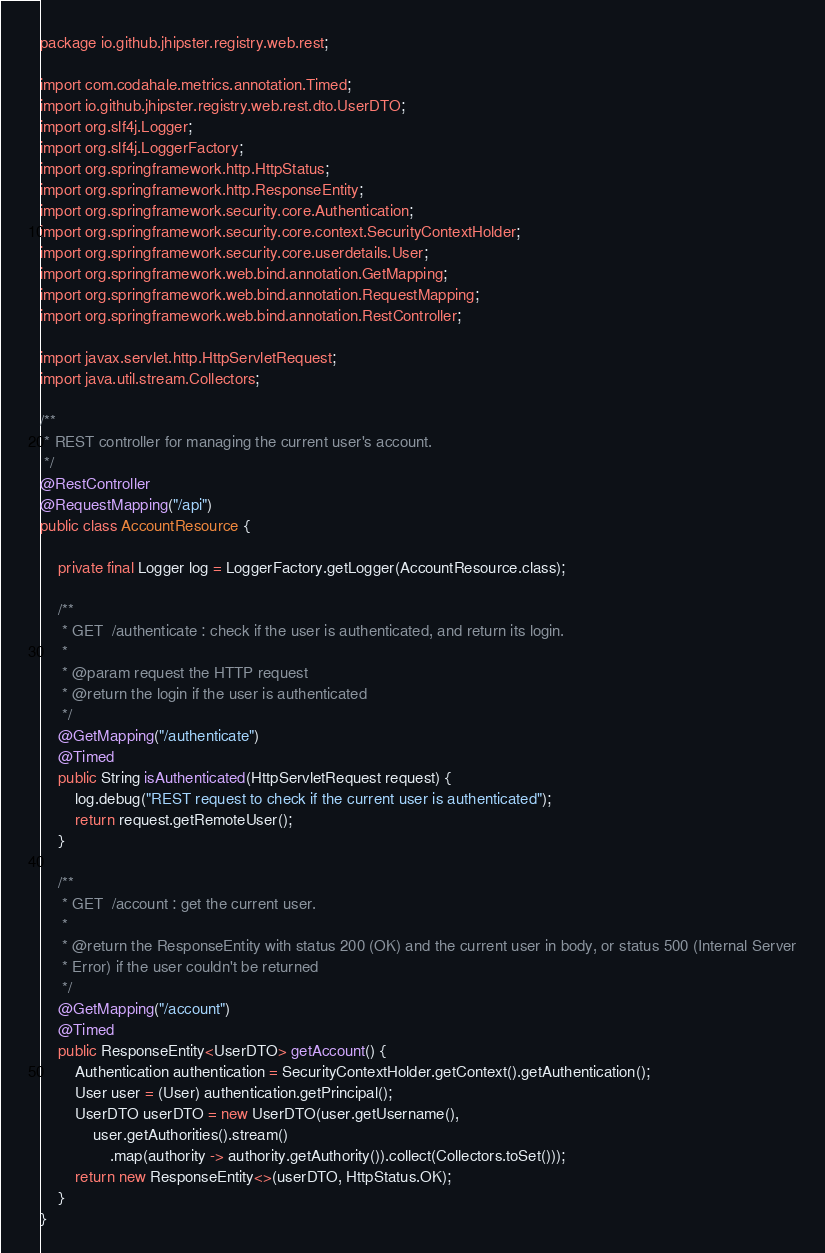Convert code to text. <code><loc_0><loc_0><loc_500><loc_500><_Java_>package io.github.jhipster.registry.web.rest;

import com.codahale.metrics.annotation.Timed;
import io.github.jhipster.registry.web.rest.dto.UserDTO;
import org.slf4j.Logger;
import org.slf4j.LoggerFactory;
import org.springframework.http.HttpStatus;
import org.springframework.http.ResponseEntity;
import org.springframework.security.core.Authentication;
import org.springframework.security.core.context.SecurityContextHolder;
import org.springframework.security.core.userdetails.User;
import org.springframework.web.bind.annotation.GetMapping;
import org.springframework.web.bind.annotation.RequestMapping;
import org.springframework.web.bind.annotation.RestController;

import javax.servlet.http.HttpServletRequest;
import java.util.stream.Collectors;

/**
 * REST controller for managing the current user's account.
 */
@RestController
@RequestMapping("/api")
public class AccountResource {

    private final Logger log = LoggerFactory.getLogger(AccountResource.class);

    /**
     * GET  /authenticate : check if the user is authenticated, and return its login.
     *
     * @param request the HTTP request
     * @return the login if the user is authenticated
     */
    @GetMapping("/authenticate")
    @Timed
    public String isAuthenticated(HttpServletRequest request) {
        log.debug("REST request to check if the current user is authenticated");
        return request.getRemoteUser();
    }

    /**
     * GET  /account : get the current user.
     *
     * @return the ResponseEntity with status 200 (OK) and the current user in body, or status 500 (Internal Server
     * Error) if the user couldn't be returned
     */
    @GetMapping("/account")
    @Timed
    public ResponseEntity<UserDTO> getAccount() {
        Authentication authentication = SecurityContextHolder.getContext().getAuthentication();
        User user = (User) authentication.getPrincipal();
        UserDTO userDTO = new UserDTO(user.getUsername(),
            user.getAuthorities().stream()
                .map(authority -> authority.getAuthority()).collect(Collectors.toSet()));
        return new ResponseEntity<>(userDTO, HttpStatus.OK);
    }
}
</code> 